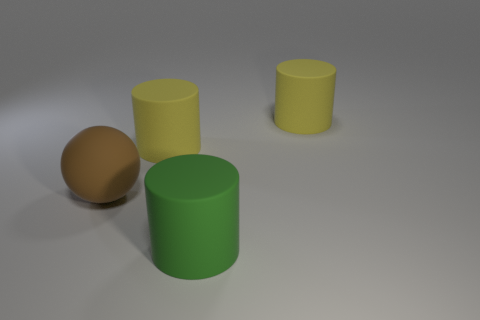What is the size of the matte sphere?
Make the answer very short. Large. Is the number of matte cylinders on the left side of the ball greater than the number of brown objects?
Provide a succinct answer. No. How many big brown balls are behind the big green thing?
Your answer should be very brief. 1. Are there any brown metal spheres of the same size as the matte sphere?
Your response must be concise. No. There is a yellow matte cylinder that is right of the large green matte object; does it have the same size as the yellow matte cylinder to the left of the green cylinder?
Provide a succinct answer. Yes. Is there a small yellow shiny object that has the same shape as the brown thing?
Your response must be concise. No. Is the number of large yellow rubber things that are in front of the big green matte cylinder the same as the number of green matte cylinders?
Ensure brevity in your answer.  No. Is the size of the brown rubber ball the same as the yellow thing that is to the right of the green object?
Keep it short and to the point. Yes. How many yellow cylinders have the same material as the big green thing?
Give a very brief answer. 2. Do the brown sphere and the green matte thing have the same size?
Offer a terse response. Yes. 